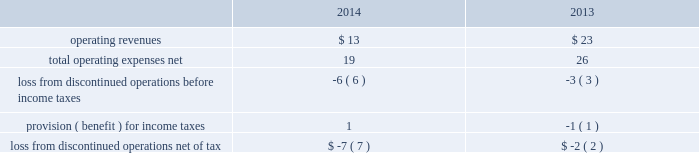During 2014 , the company closed on thirteen acquisitions of various regulated water and wastewater systems for a total aggregate purchase price of $ 9 .
Assets acquired , principally plant , totaled $ 17 .
Liabilities assumed totaled $ 8 , including $ 5 of contributions in aid of construction and assumed debt of $ 2 .
During 2013 , the company closed on fifteen acquisitions of various regulated water and wastewater systems for a total aggregate net purchase price of $ 24 .
Assets acquired , primarily utility plant , totaled $ 67 .
Liabilities assumed totaled $ 43 , including $ 26 of contributions in aid of construction and assumed debt of $ 13 .
Included in these totals was the company 2019s november 14 , 2013 acquisition of all of the capital stock of dale service corporation ( 201cdale 201d ) , a regulated wastewater utility company , for a total cash purchase price of $ 5 ( net of cash acquired of $ 7 ) , plus assumed liabilities .
The dale acquisition was accounted for as a business combination ; accordingly , operating results from november 14 , 2013 were included in the company 2019s results of operations .
The purchase price was allocated to the net tangible and intangible assets based upon their estimated fair values at the date of acquisition .
The company 2019s regulatory practice was followed whereby property , plant and equipment ( rate base ) was considered fair value for business combination purposes .
Similarly , regulatory assets and liabilities acquired were recorded at book value and are subject to regulatory approval where applicable .
The acquired debt was valued in a manner consistent with the company 2019s level 3 debt .
See note 17 2014fair value of financial instruments .
Non-cash assets acquired in the dale acquisition , primarily utility plant , totaled $ 41 ; liabilities assumed totaled $ 36 , including debt assumed of $ 13 and contributions of $ 19 .
Divestitures in november 2014 , the company completed the sale of terratec , previously included in the market-based businesses .
After post-close adjustments , net proceeds from the sale totaled $ 1 , and the company recorded a pretax loss on sale of $ 1 .
The table summarizes the operating results of discontinued operations presented in the accompanying consolidated statements of operations for the years ended december 31: .
The provision for income taxes of discontinued operations includes the recognition of tax expense related to the difference between the tax basis and book basis of assets upon the sales of terratec that resulted in taxable gains , since an election was made under section 338 ( h ) ( 10 ) of the internal revenue code to treat the sales as asset sales .
There were no assets or liabilities of discontinued operations in the accompanying consolidated balance sheets as of december 31 , 2015 and 2014. .
At what revenue multiple did awk purchase various regulated water and wastewater systems in 2014? 
Computations: (13 / 9)
Answer: 1.44444. 